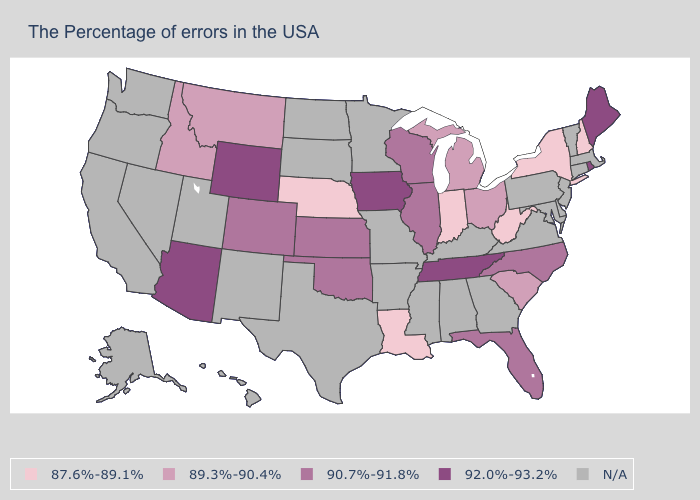Name the states that have a value in the range 89.3%-90.4%?
Be succinct. South Carolina, Ohio, Michigan, Montana, Idaho. What is the highest value in the West ?
Concise answer only. 92.0%-93.2%. What is the value of Indiana?
Short answer required. 87.6%-89.1%. Is the legend a continuous bar?
Write a very short answer. No. Name the states that have a value in the range 89.3%-90.4%?
Keep it brief. South Carolina, Ohio, Michigan, Montana, Idaho. How many symbols are there in the legend?
Short answer required. 5. What is the value of Georgia?
Concise answer only. N/A. What is the value of North Carolina?
Short answer required. 90.7%-91.8%. Does the first symbol in the legend represent the smallest category?
Concise answer only. Yes. Name the states that have a value in the range 87.6%-89.1%?
Write a very short answer. New Hampshire, New York, West Virginia, Indiana, Louisiana, Nebraska. Which states have the lowest value in the USA?
Answer briefly. New Hampshire, New York, West Virginia, Indiana, Louisiana, Nebraska. Is the legend a continuous bar?
Concise answer only. No. Which states have the lowest value in the USA?
Give a very brief answer. New Hampshire, New York, West Virginia, Indiana, Louisiana, Nebraska. Among the states that border Oklahoma , which have the highest value?
Answer briefly. Kansas, Colorado. 